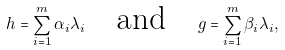<formula> <loc_0><loc_0><loc_500><loc_500>h = \sum _ { i = 1 } ^ { m } \alpha _ { i } \lambda _ { i } \quad \text {and} \quad g = \sum _ { i = 1 } ^ { m } \beta _ { i } \lambda _ { i } ,</formula> 